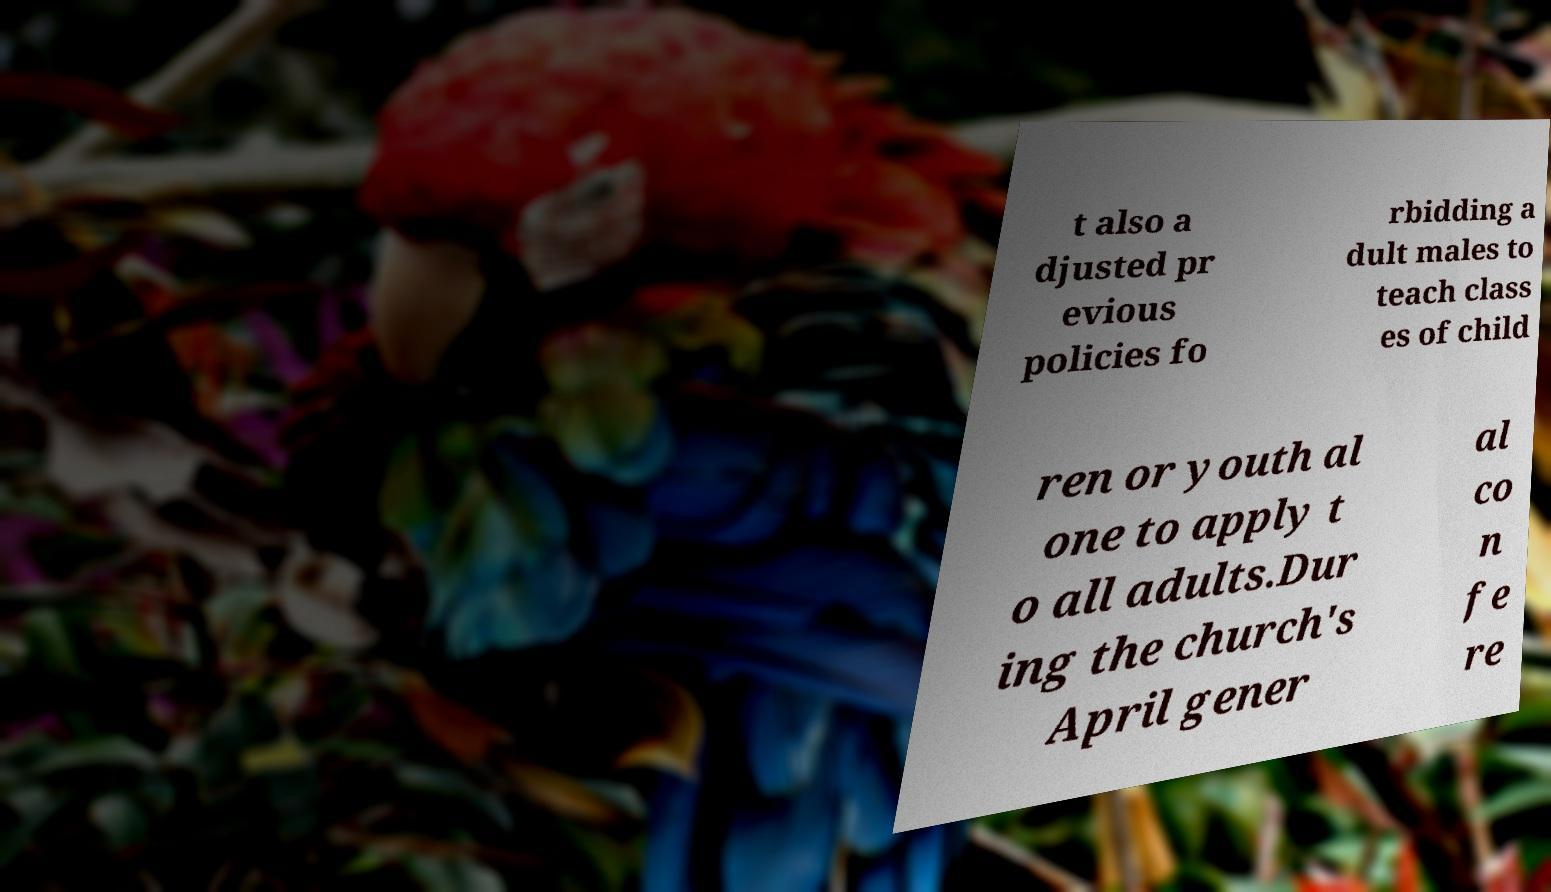For documentation purposes, I need the text within this image transcribed. Could you provide that? t also a djusted pr evious policies fo rbidding a dult males to teach class es of child ren or youth al one to apply t o all adults.Dur ing the church's April gener al co n fe re 